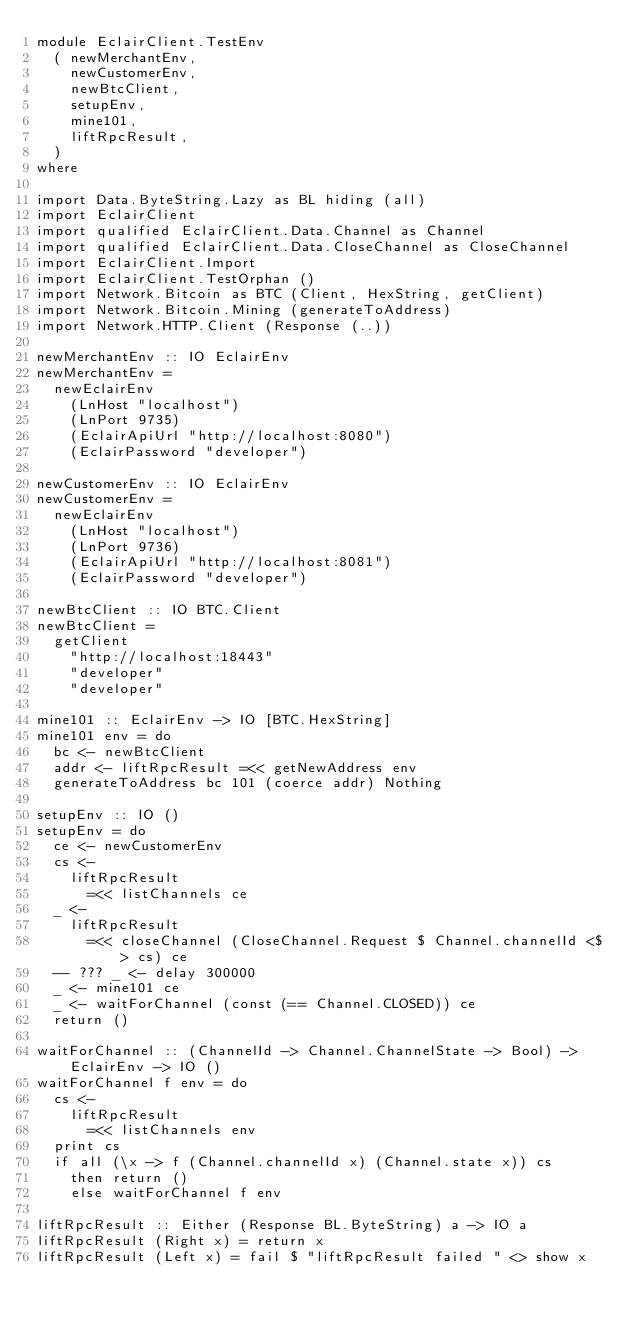Convert code to text. <code><loc_0><loc_0><loc_500><loc_500><_Haskell_>module EclairClient.TestEnv
  ( newMerchantEnv,
    newCustomerEnv,
    newBtcClient,
    setupEnv,
    mine101,
    liftRpcResult,
  )
where

import Data.ByteString.Lazy as BL hiding (all)
import EclairClient
import qualified EclairClient.Data.Channel as Channel
import qualified EclairClient.Data.CloseChannel as CloseChannel
import EclairClient.Import
import EclairClient.TestOrphan ()
import Network.Bitcoin as BTC (Client, HexString, getClient)
import Network.Bitcoin.Mining (generateToAddress)
import Network.HTTP.Client (Response (..))

newMerchantEnv :: IO EclairEnv
newMerchantEnv =
  newEclairEnv
    (LnHost "localhost")
    (LnPort 9735)
    (EclairApiUrl "http://localhost:8080")
    (EclairPassword "developer")

newCustomerEnv :: IO EclairEnv
newCustomerEnv =
  newEclairEnv
    (LnHost "localhost")
    (LnPort 9736)
    (EclairApiUrl "http://localhost:8081")
    (EclairPassword "developer")

newBtcClient :: IO BTC.Client
newBtcClient =
  getClient
    "http://localhost:18443"
    "developer"
    "developer"

mine101 :: EclairEnv -> IO [BTC.HexString]
mine101 env = do
  bc <- newBtcClient
  addr <- liftRpcResult =<< getNewAddress env
  generateToAddress bc 101 (coerce addr) Nothing

setupEnv :: IO ()
setupEnv = do
  ce <- newCustomerEnv
  cs <-
    liftRpcResult
      =<< listChannels ce
  _ <-
    liftRpcResult
      =<< closeChannel (CloseChannel.Request $ Channel.channelId <$> cs) ce
  -- ??? _ <- delay 300000
  _ <- mine101 ce
  _ <- waitForChannel (const (== Channel.CLOSED)) ce
  return ()

waitForChannel :: (ChannelId -> Channel.ChannelState -> Bool) -> EclairEnv -> IO ()
waitForChannel f env = do
  cs <-
    liftRpcResult
      =<< listChannels env
  print cs
  if all (\x -> f (Channel.channelId x) (Channel.state x)) cs
    then return ()
    else waitForChannel f env

liftRpcResult :: Either (Response BL.ByteString) a -> IO a
liftRpcResult (Right x) = return x
liftRpcResult (Left x) = fail $ "liftRpcResult failed " <> show x
</code> 